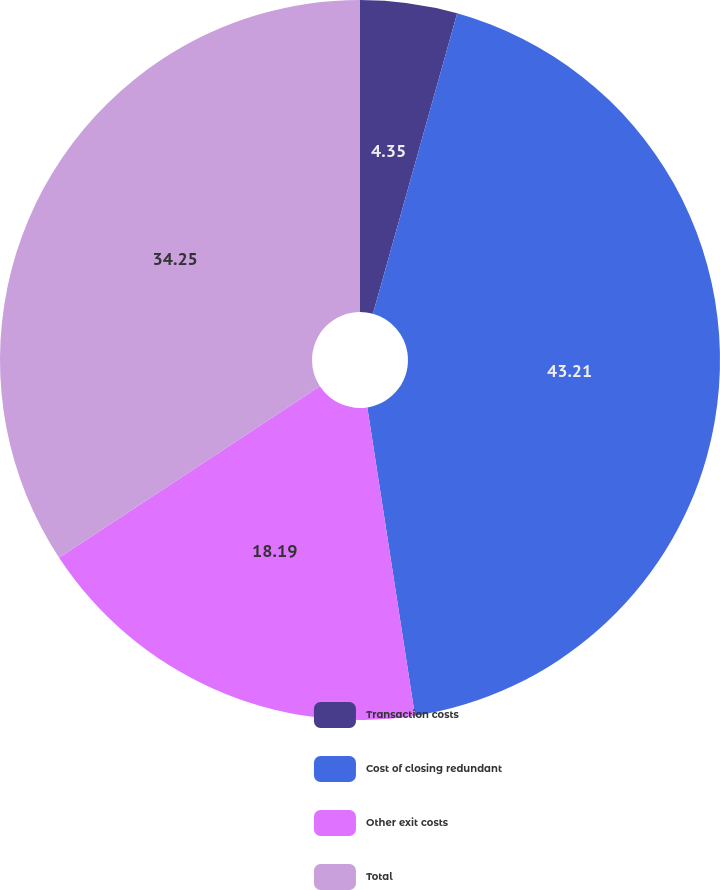Convert chart to OTSL. <chart><loc_0><loc_0><loc_500><loc_500><pie_chart><fcel>Transaction costs<fcel>Cost of closing redundant<fcel>Other exit costs<fcel>Total<nl><fcel>4.35%<fcel>43.21%<fcel>18.19%<fcel>34.25%<nl></chart> 